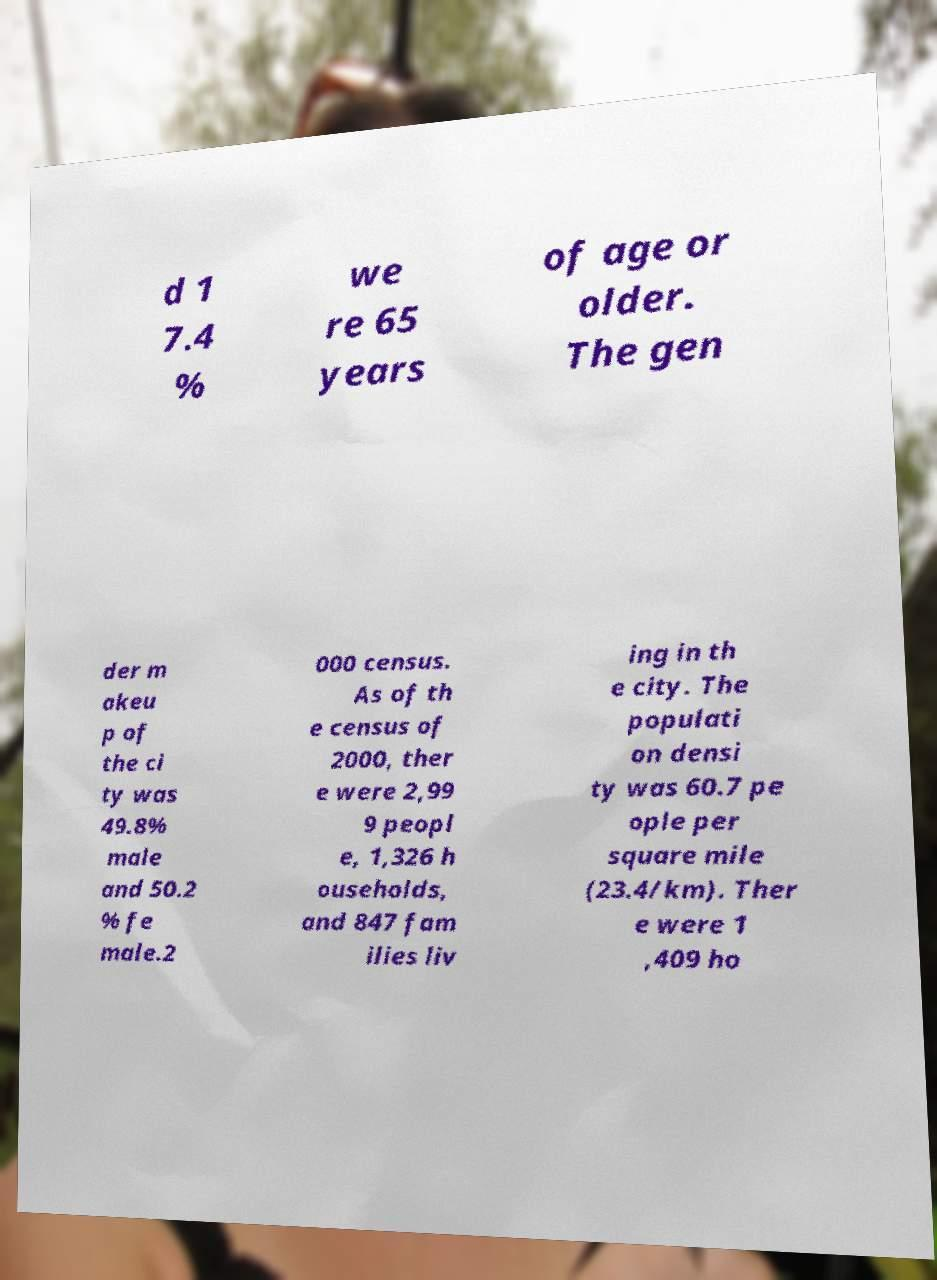Can you accurately transcribe the text from the provided image for me? d 1 7.4 % we re 65 years of age or older. The gen der m akeu p of the ci ty was 49.8% male and 50.2 % fe male.2 000 census. As of th e census of 2000, ther e were 2,99 9 peopl e, 1,326 h ouseholds, and 847 fam ilies liv ing in th e city. The populati on densi ty was 60.7 pe ople per square mile (23.4/km). Ther e were 1 ,409 ho 